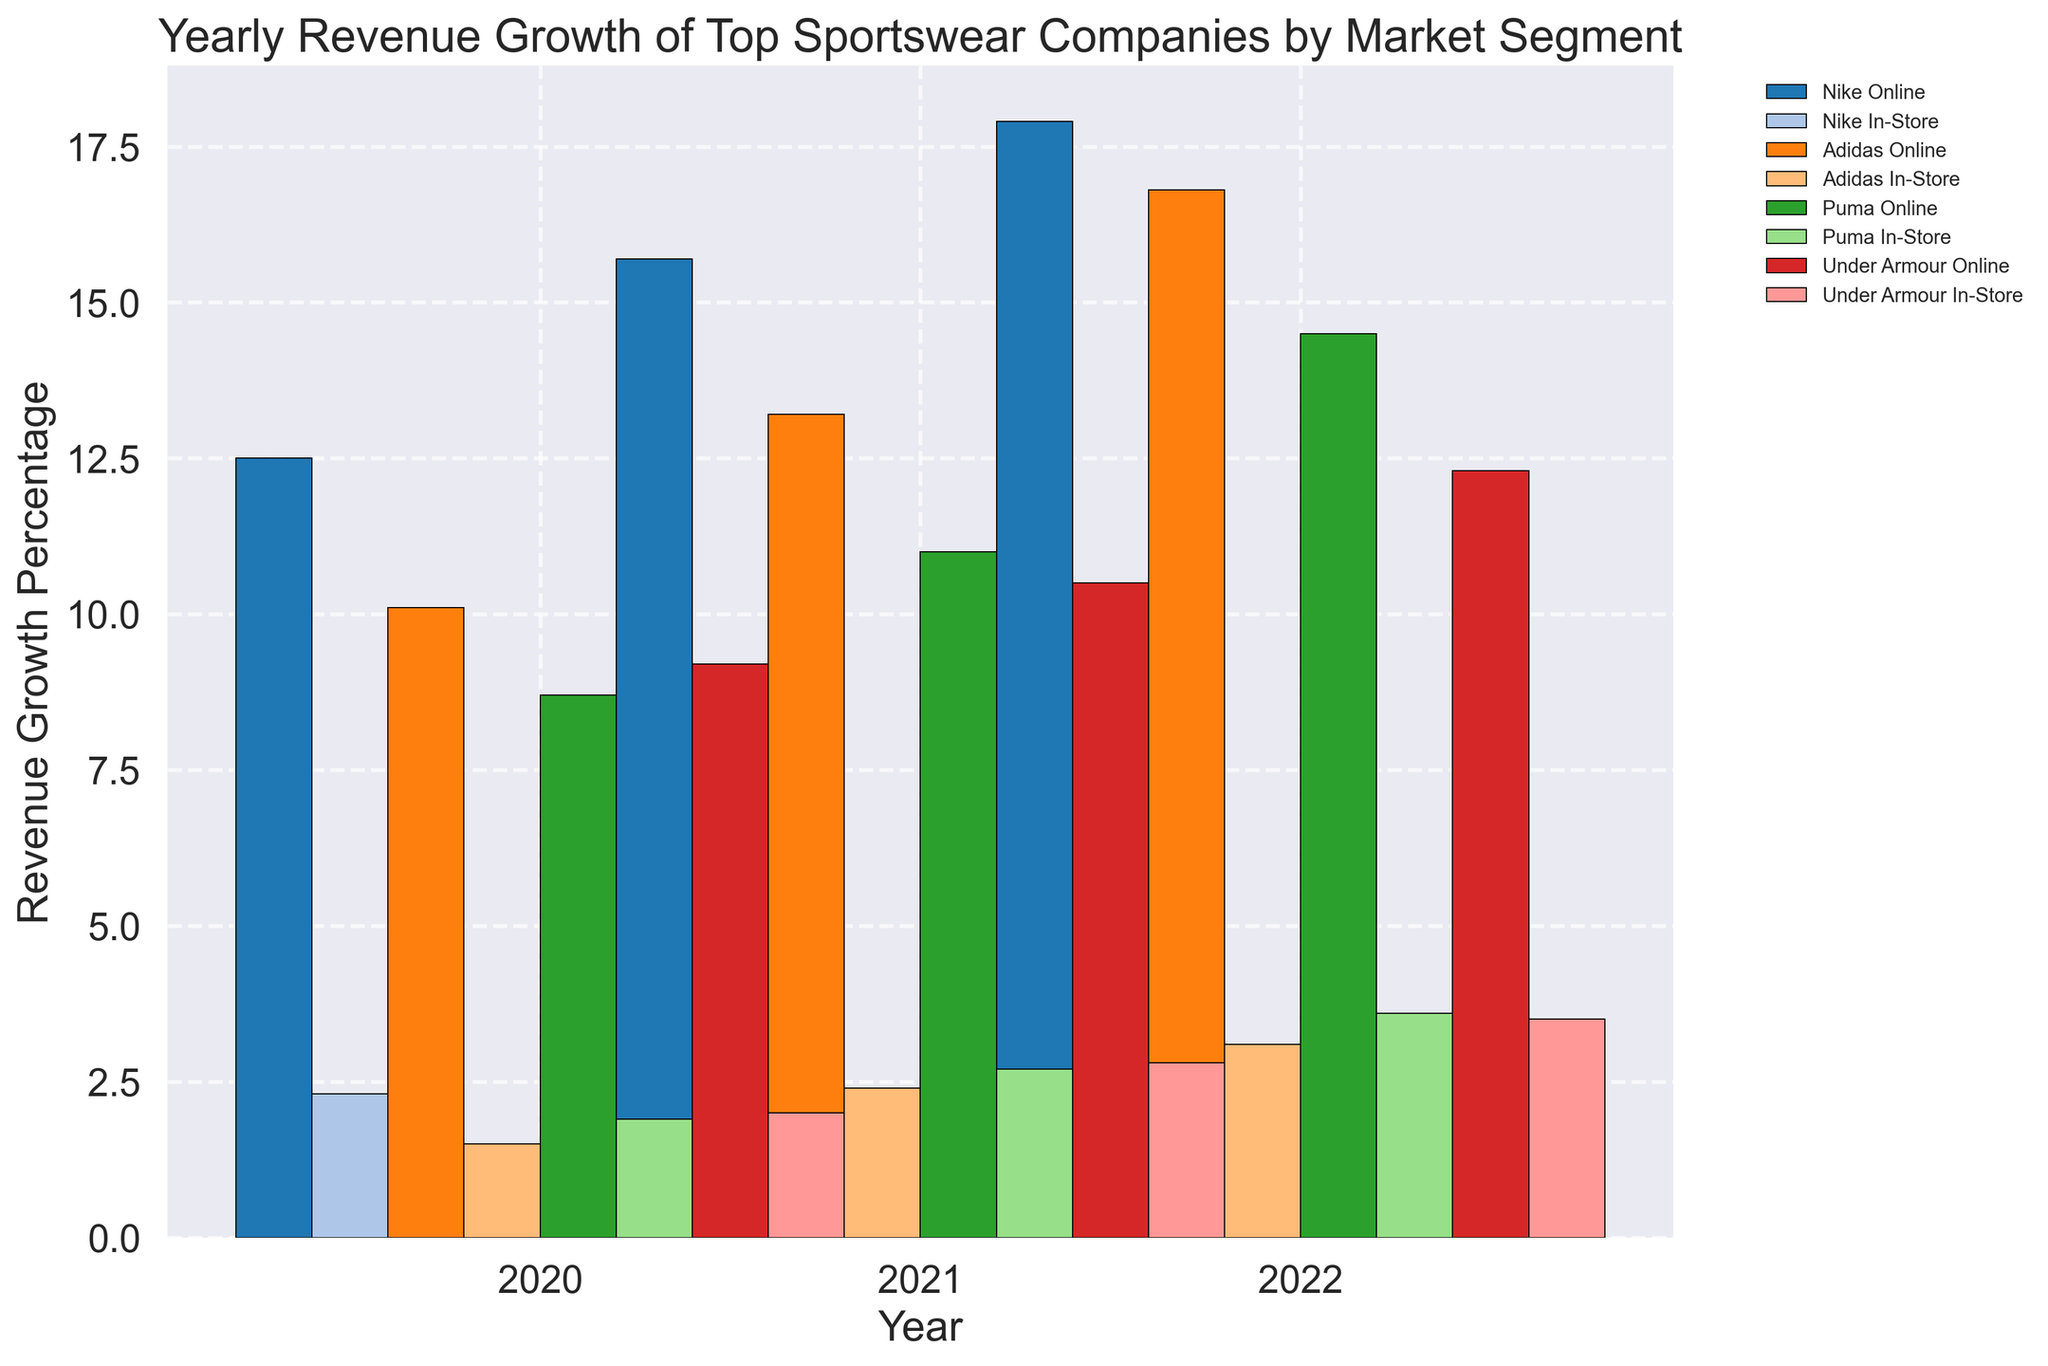Which company had the highest revenue growth in the online market segment in 2022? To determine which company had the highest revenue growth in the online segment for 2022, examine the heights of the bars labeled "Online" for each company in 2022. Nike's bar is the tallest at 17.9%.
Answer: Nike Which market segment showed greater revenue growth for Adidas in 2020? Compare the heights of the bars for Adidas' online and in-store segments in 2020. The online segment is higher at 10.1% compared to the in-store segment at 1.5%.
Answer: Online What is the total revenue growth for Under Armour in both market segments combined in 2021? For Under Armour in 2021, add the revenue growth percentages of the online (10.5%) and in-store (2.8%) segments: 10.5% + 2.8% = 13.3%.
Answer: 13.3% How did Puma's online revenue growth in 2022 compare to its in-store growth in the same year? Observe the heights of the bars for Puma in 2022. The online segment's bar is taller at 14.5%, compared to the in-store segment at 3.6%.
Answer: Online segment is higher Between Nike's in-store revenue growth and Adidas' in-store revenue growth in 2021, which was higher? Compare the bars for Nike and Adidas in the in-store segment for 2021. Nike's bar is higher at 3.8% compared to Adidas' at 2.4%.
Answer: Nike What is the average revenue growth for Nike's online segment from 2020 to 2022? Add the revenue growth percentages for Nike's online segment (12.5% in 2020, 15.7% in 2021, and 17.9% in 2022) and then divide by 3: (12.5% + 15.7% + 17.9%) / 3 = 15.37%.
Answer: 15.37% Which company had the least growth in the in-store segment in 2022? Compare the heights of the bars for the in-store segments of each company in 2022. Adidas has the lowest bar at 3.1%.
Answer: Adidas Which company showed the most consistent revenue growth in the online market segment over the three years? Look at the bar heights for each company's online segment from 2020 to 2022. Puma's growth increments from 8.7% to 11.0% to 14.5% indicate a consistent upward trend.
Answer: Puma In which year did Adidas see the highest revenue growth in the online segment? Examine the bar heights for Adidas' online segment for each year. The tallest bar is in 2022, at 16.8%.
Answer: 2022 What is the combined revenue growth for all companies in the in-store segment in 2020? Add the in-store revenue growth for Nike (2.3%), Adidas (1.5%), Puma (1.9%), and Under Armour (2.0%) in 2020: 2.3% + 1.5% + 1.9% + 2.0% = 7.7%.
Answer: 7.7% 